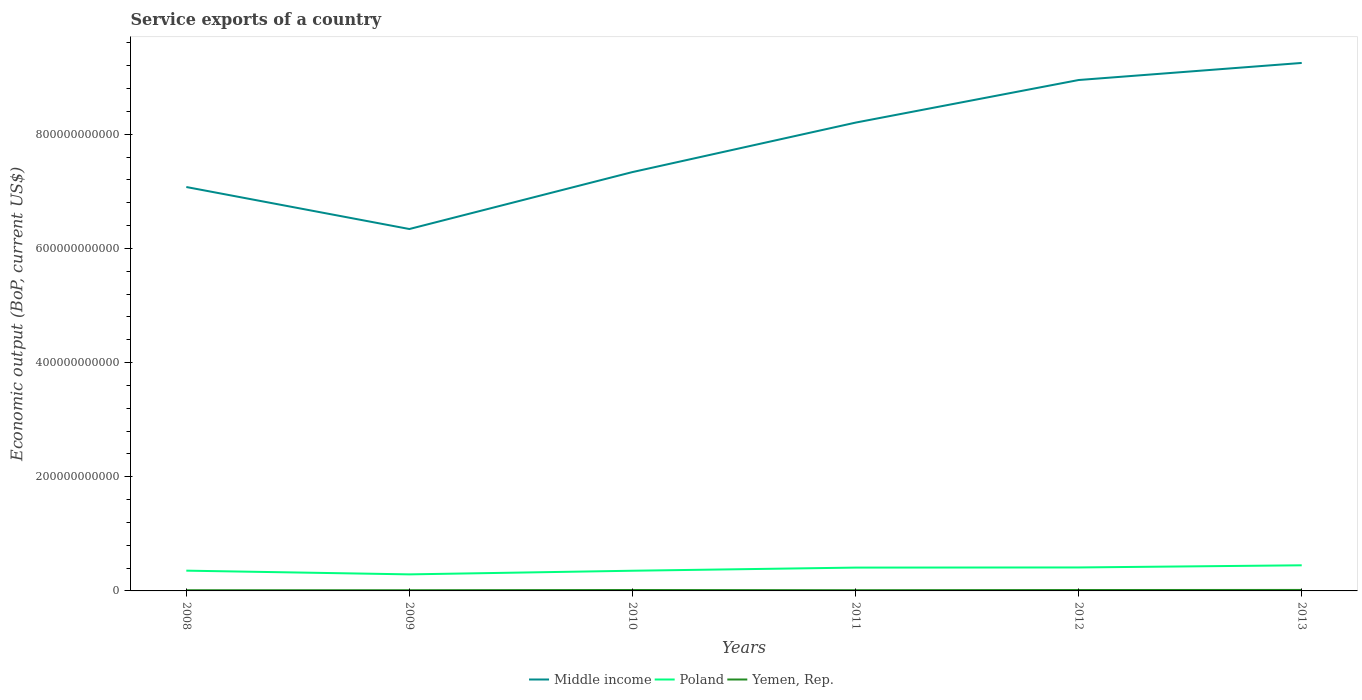How many different coloured lines are there?
Your answer should be very brief. 3. Does the line corresponding to Poland intersect with the line corresponding to Yemen, Rep.?
Keep it short and to the point. No. Is the number of lines equal to the number of legend labels?
Provide a succinct answer. Yes. Across all years, what is the maximum service exports in Middle income?
Provide a succinct answer. 6.34e+11. What is the total service exports in Yemen, Rep. in the graph?
Make the answer very short. -3.72e+08. What is the difference between the highest and the second highest service exports in Middle income?
Offer a very short reply. 2.91e+11. How many lines are there?
Your answer should be compact. 3. How many years are there in the graph?
Your response must be concise. 6. What is the difference between two consecutive major ticks on the Y-axis?
Your answer should be compact. 2.00e+11. Does the graph contain any zero values?
Provide a succinct answer. No. Does the graph contain grids?
Your response must be concise. No. How are the legend labels stacked?
Offer a very short reply. Horizontal. What is the title of the graph?
Your response must be concise. Service exports of a country. What is the label or title of the X-axis?
Provide a succinct answer. Years. What is the label or title of the Y-axis?
Provide a short and direct response. Economic output (BoP, current US$). What is the Economic output (BoP, current US$) in Middle income in 2008?
Offer a terse response. 7.08e+11. What is the Economic output (BoP, current US$) of Poland in 2008?
Provide a short and direct response. 3.55e+1. What is the Economic output (BoP, current US$) of Yemen, Rep. in 2008?
Your answer should be very brief. 1.21e+09. What is the Economic output (BoP, current US$) of Middle income in 2009?
Make the answer very short. 6.34e+11. What is the Economic output (BoP, current US$) of Poland in 2009?
Provide a short and direct response. 2.90e+1. What is the Economic output (BoP, current US$) in Yemen, Rep. in 2009?
Offer a very short reply. 1.24e+09. What is the Economic output (BoP, current US$) in Middle income in 2010?
Provide a succinct answer. 7.34e+11. What is the Economic output (BoP, current US$) of Poland in 2010?
Give a very brief answer. 3.54e+1. What is the Economic output (BoP, current US$) in Yemen, Rep. in 2010?
Keep it short and to the point. 1.62e+09. What is the Economic output (BoP, current US$) in Middle income in 2011?
Give a very brief answer. 8.20e+11. What is the Economic output (BoP, current US$) of Poland in 2011?
Your answer should be compact. 4.09e+1. What is the Economic output (BoP, current US$) in Yemen, Rep. in 2011?
Make the answer very short. 1.27e+09. What is the Economic output (BoP, current US$) in Middle income in 2012?
Your answer should be compact. 8.95e+11. What is the Economic output (BoP, current US$) in Poland in 2012?
Offer a very short reply. 4.11e+1. What is the Economic output (BoP, current US$) in Yemen, Rep. in 2012?
Provide a succinct answer. 1.58e+09. What is the Economic output (BoP, current US$) of Middle income in 2013?
Offer a very short reply. 9.25e+11. What is the Economic output (BoP, current US$) in Poland in 2013?
Keep it short and to the point. 4.49e+1. What is the Economic output (BoP, current US$) in Yemen, Rep. in 2013?
Provide a succinct answer. 1.73e+09. Across all years, what is the maximum Economic output (BoP, current US$) of Middle income?
Provide a short and direct response. 9.25e+11. Across all years, what is the maximum Economic output (BoP, current US$) in Poland?
Ensure brevity in your answer.  4.49e+1. Across all years, what is the maximum Economic output (BoP, current US$) in Yemen, Rep.?
Give a very brief answer. 1.73e+09. Across all years, what is the minimum Economic output (BoP, current US$) in Middle income?
Your response must be concise. 6.34e+11. Across all years, what is the minimum Economic output (BoP, current US$) of Poland?
Keep it short and to the point. 2.90e+1. Across all years, what is the minimum Economic output (BoP, current US$) of Yemen, Rep.?
Make the answer very short. 1.21e+09. What is the total Economic output (BoP, current US$) of Middle income in the graph?
Offer a very short reply. 4.72e+12. What is the total Economic output (BoP, current US$) in Poland in the graph?
Offer a terse response. 2.27e+11. What is the total Economic output (BoP, current US$) in Yemen, Rep. in the graph?
Your answer should be compact. 8.63e+09. What is the difference between the Economic output (BoP, current US$) in Middle income in 2008 and that in 2009?
Give a very brief answer. 7.36e+1. What is the difference between the Economic output (BoP, current US$) of Poland in 2008 and that in 2009?
Provide a short and direct response. 6.51e+09. What is the difference between the Economic output (BoP, current US$) in Yemen, Rep. in 2008 and that in 2009?
Give a very brief answer. -3.18e+07. What is the difference between the Economic output (BoP, current US$) in Middle income in 2008 and that in 2010?
Your response must be concise. -2.62e+1. What is the difference between the Economic output (BoP, current US$) of Poland in 2008 and that in 2010?
Offer a terse response. 1.49e+08. What is the difference between the Economic output (BoP, current US$) of Yemen, Rep. in 2008 and that in 2010?
Your response must be concise. -4.17e+08. What is the difference between the Economic output (BoP, current US$) of Middle income in 2008 and that in 2011?
Provide a succinct answer. -1.13e+11. What is the difference between the Economic output (BoP, current US$) of Poland in 2008 and that in 2011?
Ensure brevity in your answer.  -5.38e+09. What is the difference between the Economic output (BoP, current US$) in Yemen, Rep. in 2008 and that in 2011?
Offer a terse response. -6.19e+07. What is the difference between the Economic output (BoP, current US$) of Middle income in 2008 and that in 2012?
Ensure brevity in your answer.  -1.87e+11. What is the difference between the Economic output (BoP, current US$) of Poland in 2008 and that in 2012?
Give a very brief answer. -5.61e+09. What is the difference between the Economic output (BoP, current US$) of Yemen, Rep. in 2008 and that in 2012?
Provide a short and direct response. -3.72e+08. What is the difference between the Economic output (BoP, current US$) in Middle income in 2008 and that in 2013?
Offer a terse response. -2.17e+11. What is the difference between the Economic output (BoP, current US$) of Poland in 2008 and that in 2013?
Ensure brevity in your answer.  -9.40e+09. What is the difference between the Economic output (BoP, current US$) in Yemen, Rep. in 2008 and that in 2013?
Offer a terse response. -5.20e+08. What is the difference between the Economic output (BoP, current US$) in Middle income in 2009 and that in 2010?
Ensure brevity in your answer.  -9.98e+1. What is the difference between the Economic output (BoP, current US$) of Poland in 2009 and that in 2010?
Keep it short and to the point. -6.36e+09. What is the difference between the Economic output (BoP, current US$) of Yemen, Rep. in 2009 and that in 2010?
Provide a short and direct response. -3.85e+08. What is the difference between the Economic output (BoP, current US$) in Middle income in 2009 and that in 2011?
Offer a very short reply. -1.86e+11. What is the difference between the Economic output (BoP, current US$) of Poland in 2009 and that in 2011?
Your response must be concise. -1.19e+1. What is the difference between the Economic output (BoP, current US$) in Yemen, Rep. in 2009 and that in 2011?
Ensure brevity in your answer.  -3.02e+07. What is the difference between the Economic output (BoP, current US$) of Middle income in 2009 and that in 2012?
Your answer should be very brief. -2.61e+11. What is the difference between the Economic output (BoP, current US$) of Poland in 2009 and that in 2012?
Make the answer very short. -1.21e+1. What is the difference between the Economic output (BoP, current US$) in Yemen, Rep. in 2009 and that in 2012?
Provide a succinct answer. -3.40e+08. What is the difference between the Economic output (BoP, current US$) in Middle income in 2009 and that in 2013?
Keep it short and to the point. -2.91e+11. What is the difference between the Economic output (BoP, current US$) in Poland in 2009 and that in 2013?
Provide a succinct answer. -1.59e+1. What is the difference between the Economic output (BoP, current US$) in Yemen, Rep. in 2009 and that in 2013?
Make the answer very short. -4.88e+08. What is the difference between the Economic output (BoP, current US$) of Middle income in 2010 and that in 2011?
Offer a terse response. -8.66e+1. What is the difference between the Economic output (BoP, current US$) in Poland in 2010 and that in 2011?
Keep it short and to the point. -5.52e+09. What is the difference between the Economic output (BoP, current US$) in Yemen, Rep. in 2010 and that in 2011?
Make the answer very short. 3.55e+08. What is the difference between the Economic output (BoP, current US$) in Middle income in 2010 and that in 2012?
Offer a very short reply. -1.61e+11. What is the difference between the Economic output (BoP, current US$) of Poland in 2010 and that in 2012?
Offer a terse response. -5.76e+09. What is the difference between the Economic output (BoP, current US$) of Yemen, Rep. in 2010 and that in 2012?
Your response must be concise. 4.51e+07. What is the difference between the Economic output (BoP, current US$) in Middle income in 2010 and that in 2013?
Provide a short and direct response. -1.91e+11. What is the difference between the Economic output (BoP, current US$) of Poland in 2010 and that in 2013?
Provide a short and direct response. -9.55e+09. What is the difference between the Economic output (BoP, current US$) of Yemen, Rep. in 2010 and that in 2013?
Offer a terse response. -1.03e+08. What is the difference between the Economic output (BoP, current US$) of Middle income in 2011 and that in 2012?
Make the answer very short. -7.46e+1. What is the difference between the Economic output (BoP, current US$) of Poland in 2011 and that in 2012?
Make the answer very short. -2.36e+08. What is the difference between the Economic output (BoP, current US$) of Yemen, Rep. in 2011 and that in 2012?
Your answer should be very brief. -3.10e+08. What is the difference between the Economic output (BoP, current US$) in Middle income in 2011 and that in 2013?
Your response must be concise. -1.05e+11. What is the difference between the Economic output (BoP, current US$) in Poland in 2011 and that in 2013?
Offer a very short reply. -4.02e+09. What is the difference between the Economic output (BoP, current US$) in Yemen, Rep. in 2011 and that in 2013?
Keep it short and to the point. -4.58e+08. What is the difference between the Economic output (BoP, current US$) in Middle income in 2012 and that in 2013?
Ensure brevity in your answer.  -2.99e+1. What is the difference between the Economic output (BoP, current US$) of Poland in 2012 and that in 2013?
Your response must be concise. -3.79e+09. What is the difference between the Economic output (BoP, current US$) of Yemen, Rep. in 2012 and that in 2013?
Your answer should be compact. -1.48e+08. What is the difference between the Economic output (BoP, current US$) of Middle income in 2008 and the Economic output (BoP, current US$) of Poland in 2009?
Your response must be concise. 6.79e+11. What is the difference between the Economic output (BoP, current US$) in Middle income in 2008 and the Economic output (BoP, current US$) in Yemen, Rep. in 2009?
Provide a short and direct response. 7.06e+11. What is the difference between the Economic output (BoP, current US$) in Poland in 2008 and the Economic output (BoP, current US$) in Yemen, Rep. in 2009?
Offer a very short reply. 3.43e+1. What is the difference between the Economic output (BoP, current US$) in Middle income in 2008 and the Economic output (BoP, current US$) in Poland in 2010?
Your answer should be very brief. 6.72e+11. What is the difference between the Economic output (BoP, current US$) in Middle income in 2008 and the Economic output (BoP, current US$) in Yemen, Rep. in 2010?
Ensure brevity in your answer.  7.06e+11. What is the difference between the Economic output (BoP, current US$) in Poland in 2008 and the Economic output (BoP, current US$) in Yemen, Rep. in 2010?
Your answer should be compact. 3.39e+1. What is the difference between the Economic output (BoP, current US$) in Middle income in 2008 and the Economic output (BoP, current US$) in Poland in 2011?
Offer a very short reply. 6.67e+11. What is the difference between the Economic output (BoP, current US$) of Middle income in 2008 and the Economic output (BoP, current US$) of Yemen, Rep. in 2011?
Offer a terse response. 7.06e+11. What is the difference between the Economic output (BoP, current US$) of Poland in 2008 and the Economic output (BoP, current US$) of Yemen, Rep. in 2011?
Ensure brevity in your answer.  3.42e+1. What is the difference between the Economic output (BoP, current US$) in Middle income in 2008 and the Economic output (BoP, current US$) in Poland in 2012?
Your answer should be very brief. 6.66e+11. What is the difference between the Economic output (BoP, current US$) of Middle income in 2008 and the Economic output (BoP, current US$) of Yemen, Rep. in 2012?
Ensure brevity in your answer.  7.06e+11. What is the difference between the Economic output (BoP, current US$) in Poland in 2008 and the Economic output (BoP, current US$) in Yemen, Rep. in 2012?
Your answer should be compact. 3.39e+1. What is the difference between the Economic output (BoP, current US$) of Middle income in 2008 and the Economic output (BoP, current US$) of Poland in 2013?
Make the answer very short. 6.63e+11. What is the difference between the Economic output (BoP, current US$) in Middle income in 2008 and the Economic output (BoP, current US$) in Yemen, Rep. in 2013?
Your response must be concise. 7.06e+11. What is the difference between the Economic output (BoP, current US$) in Poland in 2008 and the Economic output (BoP, current US$) in Yemen, Rep. in 2013?
Provide a short and direct response. 3.38e+1. What is the difference between the Economic output (BoP, current US$) of Middle income in 2009 and the Economic output (BoP, current US$) of Poland in 2010?
Provide a short and direct response. 5.99e+11. What is the difference between the Economic output (BoP, current US$) of Middle income in 2009 and the Economic output (BoP, current US$) of Yemen, Rep. in 2010?
Ensure brevity in your answer.  6.32e+11. What is the difference between the Economic output (BoP, current US$) in Poland in 2009 and the Economic output (BoP, current US$) in Yemen, Rep. in 2010?
Provide a short and direct response. 2.74e+1. What is the difference between the Economic output (BoP, current US$) of Middle income in 2009 and the Economic output (BoP, current US$) of Poland in 2011?
Ensure brevity in your answer.  5.93e+11. What is the difference between the Economic output (BoP, current US$) of Middle income in 2009 and the Economic output (BoP, current US$) of Yemen, Rep. in 2011?
Offer a terse response. 6.33e+11. What is the difference between the Economic output (BoP, current US$) of Poland in 2009 and the Economic output (BoP, current US$) of Yemen, Rep. in 2011?
Make the answer very short. 2.77e+1. What is the difference between the Economic output (BoP, current US$) in Middle income in 2009 and the Economic output (BoP, current US$) in Poland in 2012?
Your answer should be very brief. 5.93e+11. What is the difference between the Economic output (BoP, current US$) in Middle income in 2009 and the Economic output (BoP, current US$) in Yemen, Rep. in 2012?
Give a very brief answer. 6.32e+11. What is the difference between the Economic output (BoP, current US$) of Poland in 2009 and the Economic output (BoP, current US$) of Yemen, Rep. in 2012?
Keep it short and to the point. 2.74e+1. What is the difference between the Economic output (BoP, current US$) in Middle income in 2009 and the Economic output (BoP, current US$) in Poland in 2013?
Your answer should be compact. 5.89e+11. What is the difference between the Economic output (BoP, current US$) of Middle income in 2009 and the Economic output (BoP, current US$) of Yemen, Rep. in 2013?
Offer a very short reply. 6.32e+11. What is the difference between the Economic output (BoP, current US$) of Poland in 2009 and the Economic output (BoP, current US$) of Yemen, Rep. in 2013?
Provide a succinct answer. 2.73e+1. What is the difference between the Economic output (BoP, current US$) in Middle income in 2010 and the Economic output (BoP, current US$) in Poland in 2011?
Ensure brevity in your answer.  6.93e+11. What is the difference between the Economic output (BoP, current US$) of Middle income in 2010 and the Economic output (BoP, current US$) of Yemen, Rep. in 2011?
Make the answer very short. 7.32e+11. What is the difference between the Economic output (BoP, current US$) of Poland in 2010 and the Economic output (BoP, current US$) of Yemen, Rep. in 2011?
Your answer should be compact. 3.41e+1. What is the difference between the Economic output (BoP, current US$) in Middle income in 2010 and the Economic output (BoP, current US$) in Poland in 2012?
Ensure brevity in your answer.  6.93e+11. What is the difference between the Economic output (BoP, current US$) of Middle income in 2010 and the Economic output (BoP, current US$) of Yemen, Rep. in 2012?
Keep it short and to the point. 7.32e+11. What is the difference between the Economic output (BoP, current US$) in Poland in 2010 and the Economic output (BoP, current US$) in Yemen, Rep. in 2012?
Your answer should be compact. 3.38e+1. What is the difference between the Economic output (BoP, current US$) in Middle income in 2010 and the Economic output (BoP, current US$) in Poland in 2013?
Provide a short and direct response. 6.89e+11. What is the difference between the Economic output (BoP, current US$) in Middle income in 2010 and the Economic output (BoP, current US$) in Yemen, Rep. in 2013?
Offer a very short reply. 7.32e+11. What is the difference between the Economic output (BoP, current US$) in Poland in 2010 and the Economic output (BoP, current US$) in Yemen, Rep. in 2013?
Ensure brevity in your answer.  3.36e+1. What is the difference between the Economic output (BoP, current US$) in Middle income in 2011 and the Economic output (BoP, current US$) in Poland in 2012?
Provide a short and direct response. 7.79e+11. What is the difference between the Economic output (BoP, current US$) of Middle income in 2011 and the Economic output (BoP, current US$) of Yemen, Rep. in 2012?
Keep it short and to the point. 8.19e+11. What is the difference between the Economic output (BoP, current US$) in Poland in 2011 and the Economic output (BoP, current US$) in Yemen, Rep. in 2012?
Provide a short and direct response. 3.93e+1. What is the difference between the Economic output (BoP, current US$) in Middle income in 2011 and the Economic output (BoP, current US$) in Poland in 2013?
Keep it short and to the point. 7.75e+11. What is the difference between the Economic output (BoP, current US$) of Middle income in 2011 and the Economic output (BoP, current US$) of Yemen, Rep. in 2013?
Give a very brief answer. 8.19e+11. What is the difference between the Economic output (BoP, current US$) in Poland in 2011 and the Economic output (BoP, current US$) in Yemen, Rep. in 2013?
Your answer should be very brief. 3.92e+1. What is the difference between the Economic output (BoP, current US$) in Middle income in 2012 and the Economic output (BoP, current US$) in Poland in 2013?
Offer a very short reply. 8.50e+11. What is the difference between the Economic output (BoP, current US$) of Middle income in 2012 and the Economic output (BoP, current US$) of Yemen, Rep. in 2013?
Provide a short and direct response. 8.93e+11. What is the difference between the Economic output (BoP, current US$) of Poland in 2012 and the Economic output (BoP, current US$) of Yemen, Rep. in 2013?
Make the answer very short. 3.94e+1. What is the average Economic output (BoP, current US$) in Middle income per year?
Ensure brevity in your answer.  7.86e+11. What is the average Economic output (BoP, current US$) of Poland per year?
Give a very brief answer. 3.78e+1. What is the average Economic output (BoP, current US$) of Yemen, Rep. per year?
Your answer should be compact. 1.44e+09. In the year 2008, what is the difference between the Economic output (BoP, current US$) in Middle income and Economic output (BoP, current US$) in Poland?
Keep it short and to the point. 6.72e+11. In the year 2008, what is the difference between the Economic output (BoP, current US$) in Middle income and Economic output (BoP, current US$) in Yemen, Rep.?
Offer a very short reply. 7.06e+11. In the year 2008, what is the difference between the Economic output (BoP, current US$) in Poland and Economic output (BoP, current US$) in Yemen, Rep.?
Make the answer very short. 3.43e+1. In the year 2009, what is the difference between the Economic output (BoP, current US$) of Middle income and Economic output (BoP, current US$) of Poland?
Make the answer very short. 6.05e+11. In the year 2009, what is the difference between the Economic output (BoP, current US$) of Middle income and Economic output (BoP, current US$) of Yemen, Rep.?
Your answer should be very brief. 6.33e+11. In the year 2009, what is the difference between the Economic output (BoP, current US$) in Poland and Economic output (BoP, current US$) in Yemen, Rep.?
Give a very brief answer. 2.78e+1. In the year 2010, what is the difference between the Economic output (BoP, current US$) of Middle income and Economic output (BoP, current US$) of Poland?
Provide a succinct answer. 6.98e+11. In the year 2010, what is the difference between the Economic output (BoP, current US$) of Middle income and Economic output (BoP, current US$) of Yemen, Rep.?
Give a very brief answer. 7.32e+11. In the year 2010, what is the difference between the Economic output (BoP, current US$) of Poland and Economic output (BoP, current US$) of Yemen, Rep.?
Your answer should be compact. 3.37e+1. In the year 2011, what is the difference between the Economic output (BoP, current US$) in Middle income and Economic output (BoP, current US$) in Poland?
Your answer should be very brief. 7.79e+11. In the year 2011, what is the difference between the Economic output (BoP, current US$) of Middle income and Economic output (BoP, current US$) of Yemen, Rep.?
Ensure brevity in your answer.  8.19e+11. In the year 2011, what is the difference between the Economic output (BoP, current US$) of Poland and Economic output (BoP, current US$) of Yemen, Rep.?
Offer a terse response. 3.96e+1. In the year 2012, what is the difference between the Economic output (BoP, current US$) in Middle income and Economic output (BoP, current US$) in Poland?
Provide a short and direct response. 8.54e+11. In the year 2012, what is the difference between the Economic output (BoP, current US$) in Middle income and Economic output (BoP, current US$) in Yemen, Rep.?
Make the answer very short. 8.93e+11. In the year 2012, what is the difference between the Economic output (BoP, current US$) of Poland and Economic output (BoP, current US$) of Yemen, Rep.?
Ensure brevity in your answer.  3.95e+1. In the year 2013, what is the difference between the Economic output (BoP, current US$) of Middle income and Economic output (BoP, current US$) of Poland?
Provide a succinct answer. 8.80e+11. In the year 2013, what is the difference between the Economic output (BoP, current US$) in Middle income and Economic output (BoP, current US$) in Yemen, Rep.?
Your response must be concise. 9.23e+11. In the year 2013, what is the difference between the Economic output (BoP, current US$) of Poland and Economic output (BoP, current US$) of Yemen, Rep.?
Give a very brief answer. 4.32e+1. What is the ratio of the Economic output (BoP, current US$) of Middle income in 2008 to that in 2009?
Provide a short and direct response. 1.12. What is the ratio of the Economic output (BoP, current US$) of Poland in 2008 to that in 2009?
Your response must be concise. 1.22. What is the ratio of the Economic output (BoP, current US$) in Yemen, Rep. in 2008 to that in 2009?
Make the answer very short. 0.97. What is the ratio of the Economic output (BoP, current US$) in Middle income in 2008 to that in 2010?
Give a very brief answer. 0.96. What is the ratio of the Economic output (BoP, current US$) of Yemen, Rep. in 2008 to that in 2010?
Your response must be concise. 0.74. What is the ratio of the Economic output (BoP, current US$) of Middle income in 2008 to that in 2011?
Offer a very short reply. 0.86. What is the ratio of the Economic output (BoP, current US$) of Poland in 2008 to that in 2011?
Your answer should be very brief. 0.87. What is the ratio of the Economic output (BoP, current US$) of Yemen, Rep. in 2008 to that in 2011?
Give a very brief answer. 0.95. What is the ratio of the Economic output (BoP, current US$) of Middle income in 2008 to that in 2012?
Your answer should be very brief. 0.79. What is the ratio of the Economic output (BoP, current US$) of Poland in 2008 to that in 2012?
Your answer should be compact. 0.86. What is the ratio of the Economic output (BoP, current US$) in Yemen, Rep. in 2008 to that in 2012?
Provide a succinct answer. 0.76. What is the ratio of the Economic output (BoP, current US$) in Middle income in 2008 to that in 2013?
Make the answer very short. 0.77. What is the ratio of the Economic output (BoP, current US$) of Poland in 2008 to that in 2013?
Your answer should be very brief. 0.79. What is the ratio of the Economic output (BoP, current US$) in Yemen, Rep. in 2008 to that in 2013?
Offer a very short reply. 0.7. What is the ratio of the Economic output (BoP, current US$) of Middle income in 2009 to that in 2010?
Make the answer very short. 0.86. What is the ratio of the Economic output (BoP, current US$) of Poland in 2009 to that in 2010?
Offer a very short reply. 0.82. What is the ratio of the Economic output (BoP, current US$) of Yemen, Rep. in 2009 to that in 2010?
Provide a succinct answer. 0.76. What is the ratio of the Economic output (BoP, current US$) in Middle income in 2009 to that in 2011?
Offer a terse response. 0.77. What is the ratio of the Economic output (BoP, current US$) of Poland in 2009 to that in 2011?
Keep it short and to the point. 0.71. What is the ratio of the Economic output (BoP, current US$) in Yemen, Rep. in 2009 to that in 2011?
Offer a very short reply. 0.98. What is the ratio of the Economic output (BoP, current US$) of Middle income in 2009 to that in 2012?
Offer a terse response. 0.71. What is the ratio of the Economic output (BoP, current US$) in Poland in 2009 to that in 2012?
Give a very brief answer. 0.71. What is the ratio of the Economic output (BoP, current US$) of Yemen, Rep. in 2009 to that in 2012?
Offer a very short reply. 0.78. What is the ratio of the Economic output (BoP, current US$) in Middle income in 2009 to that in 2013?
Ensure brevity in your answer.  0.69. What is the ratio of the Economic output (BoP, current US$) in Poland in 2009 to that in 2013?
Your response must be concise. 0.65. What is the ratio of the Economic output (BoP, current US$) in Yemen, Rep. in 2009 to that in 2013?
Offer a terse response. 0.72. What is the ratio of the Economic output (BoP, current US$) in Middle income in 2010 to that in 2011?
Keep it short and to the point. 0.89. What is the ratio of the Economic output (BoP, current US$) of Poland in 2010 to that in 2011?
Provide a succinct answer. 0.86. What is the ratio of the Economic output (BoP, current US$) in Yemen, Rep. in 2010 to that in 2011?
Provide a succinct answer. 1.28. What is the ratio of the Economic output (BoP, current US$) of Middle income in 2010 to that in 2012?
Provide a short and direct response. 0.82. What is the ratio of the Economic output (BoP, current US$) in Poland in 2010 to that in 2012?
Offer a terse response. 0.86. What is the ratio of the Economic output (BoP, current US$) in Yemen, Rep. in 2010 to that in 2012?
Your answer should be compact. 1.03. What is the ratio of the Economic output (BoP, current US$) of Middle income in 2010 to that in 2013?
Offer a terse response. 0.79. What is the ratio of the Economic output (BoP, current US$) in Poland in 2010 to that in 2013?
Offer a very short reply. 0.79. What is the ratio of the Economic output (BoP, current US$) in Yemen, Rep. in 2010 to that in 2013?
Provide a short and direct response. 0.94. What is the ratio of the Economic output (BoP, current US$) of Middle income in 2011 to that in 2012?
Ensure brevity in your answer.  0.92. What is the ratio of the Economic output (BoP, current US$) in Poland in 2011 to that in 2012?
Provide a short and direct response. 0.99. What is the ratio of the Economic output (BoP, current US$) of Yemen, Rep. in 2011 to that in 2012?
Provide a succinct answer. 0.8. What is the ratio of the Economic output (BoP, current US$) of Middle income in 2011 to that in 2013?
Offer a terse response. 0.89. What is the ratio of the Economic output (BoP, current US$) of Poland in 2011 to that in 2013?
Your response must be concise. 0.91. What is the ratio of the Economic output (BoP, current US$) of Yemen, Rep. in 2011 to that in 2013?
Provide a short and direct response. 0.73. What is the ratio of the Economic output (BoP, current US$) in Middle income in 2012 to that in 2013?
Provide a succinct answer. 0.97. What is the ratio of the Economic output (BoP, current US$) in Poland in 2012 to that in 2013?
Provide a succinct answer. 0.92. What is the ratio of the Economic output (BoP, current US$) of Yemen, Rep. in 2012 to that in 2013?
Your response must be concise. 0.91. What is the difference between the highest and the second highest Economic output (BoP, current US$) of Middle income?
Your response must be concise. 2.99e+1. What is the difference between the highest and the second highest Economic output (BoP, current US$) of Poland?
Give a very brief answer. 3.79e+09. What is the difference between the highest and the second highest Economic output (BoP, current US$) of Yemen, Rep.?
Offer a very short reply. 1.03e+08. What is the difference between the highest and the lowest Economic output (BoP, current US$) of Middle income?
Provide a succinct answer. 2.91e+11. What is the difference between the highest and the lowest Economic output (BoP, current US$) in Poland?
Provide a short and direct response. 1.59e+1. What is the difference between the highest and the lowest Economic output (BoP, current US$) of Yemen, Rep.?
Provide a short and direct response. 5.20e+08. 